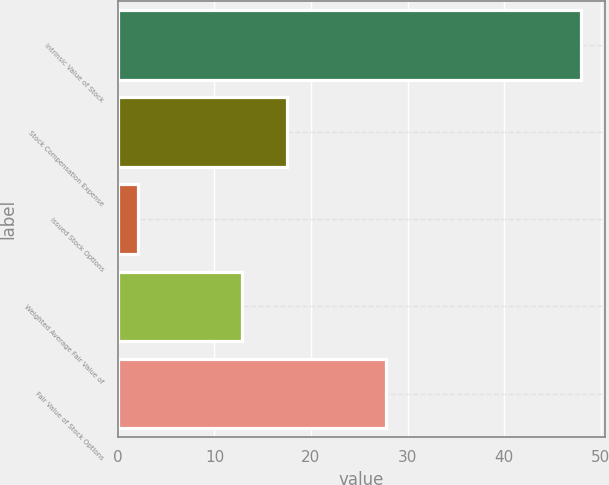Convert chart to OTSL. <chart><loc_0><loc_0><loc_500><loc_500><bar_chart><fcel>Intrinsic Value of Stock<fcel>Stock Compensation Expense<fcel>Issued Stock Options<fcel>Weighted Average Fair Value of<fcel>Fair Value of Stock Options<nl><fcel>48<fcel>17.49<fcel>2.1<fcel>12.9<fcel>27.8<nl></chart> 